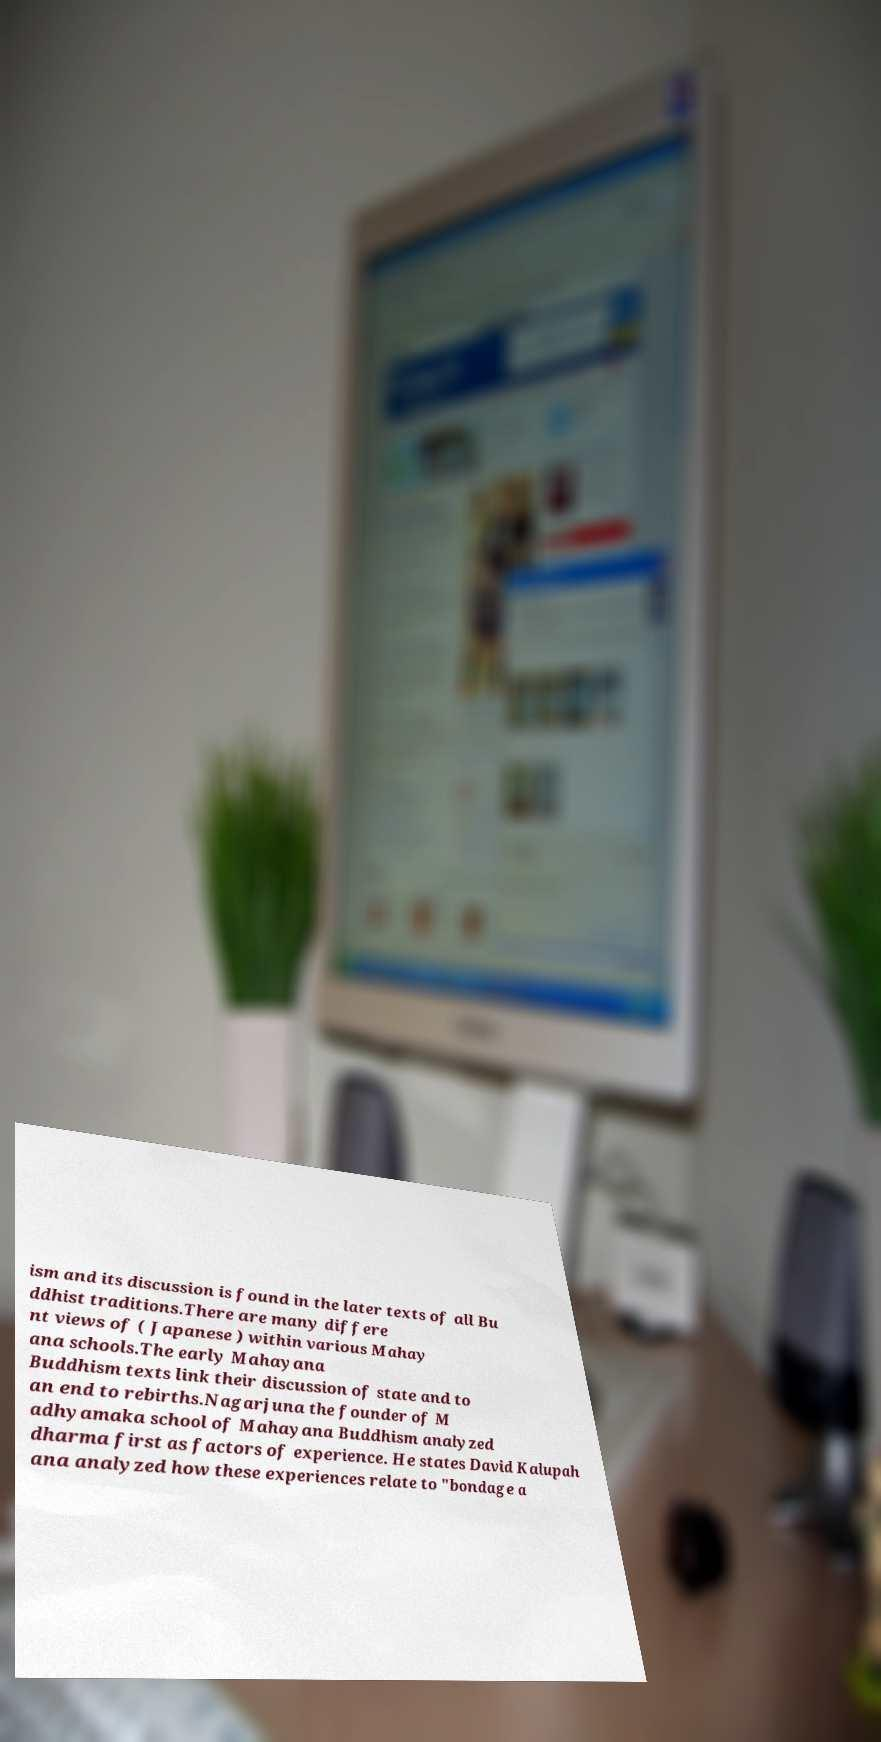Can you accurately transcribe the text from the provided image for me? ism and its discussion is found in the later texts of all Bu ddhist traditions.There are many differe nt views of ( Japanese ) within various Mahay ana schools.The early Mahayana Buddhism texts link their discussion of state and to an end to rebirths.Nagarjuna the founder of M adhyamaka school of Mahayana Buddhism analyzed dharma first as factors of experience. He states David Kalupah ana analyzed how these experiences relate to "bondage a 